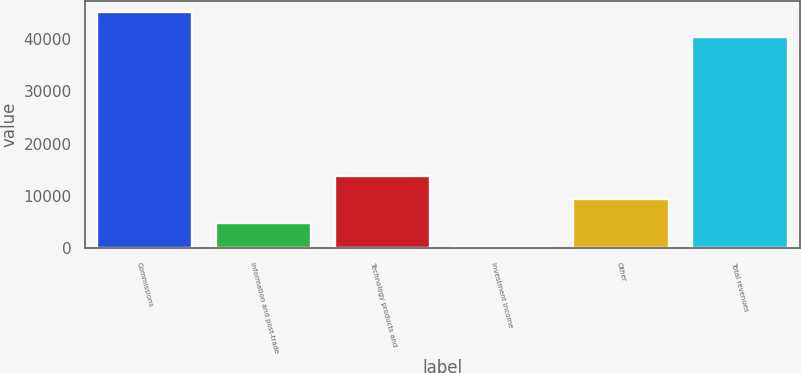Convert chart. <chart><loc_0><loc_0><loc_500><loc_500><bar_chart><fcel>Commissions<fcel>Information and post-trade<fcel>Technology products and<fcel>Investment income<fcel>Other<fcel>Total revenues<nl><fcel>45083<fcel>4834.1<fcel>13778.3<fcel>362<fcel>9306.2<fcel>40324<nl></chart> 